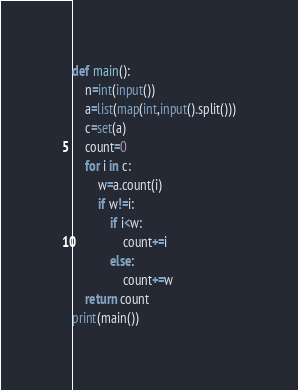<code> <loc_0><loc_0><loc_500><loc_500><_Python_>def main():
    n=int(input())
    a=list(map(int,input().split()))
    c=set(a)
    count=0
    for i in c:
        w=a.count(i)
        if w!=i:
            if i<w:
                count+=i
            else:
                count+=w
    return count
print(main())</code> 